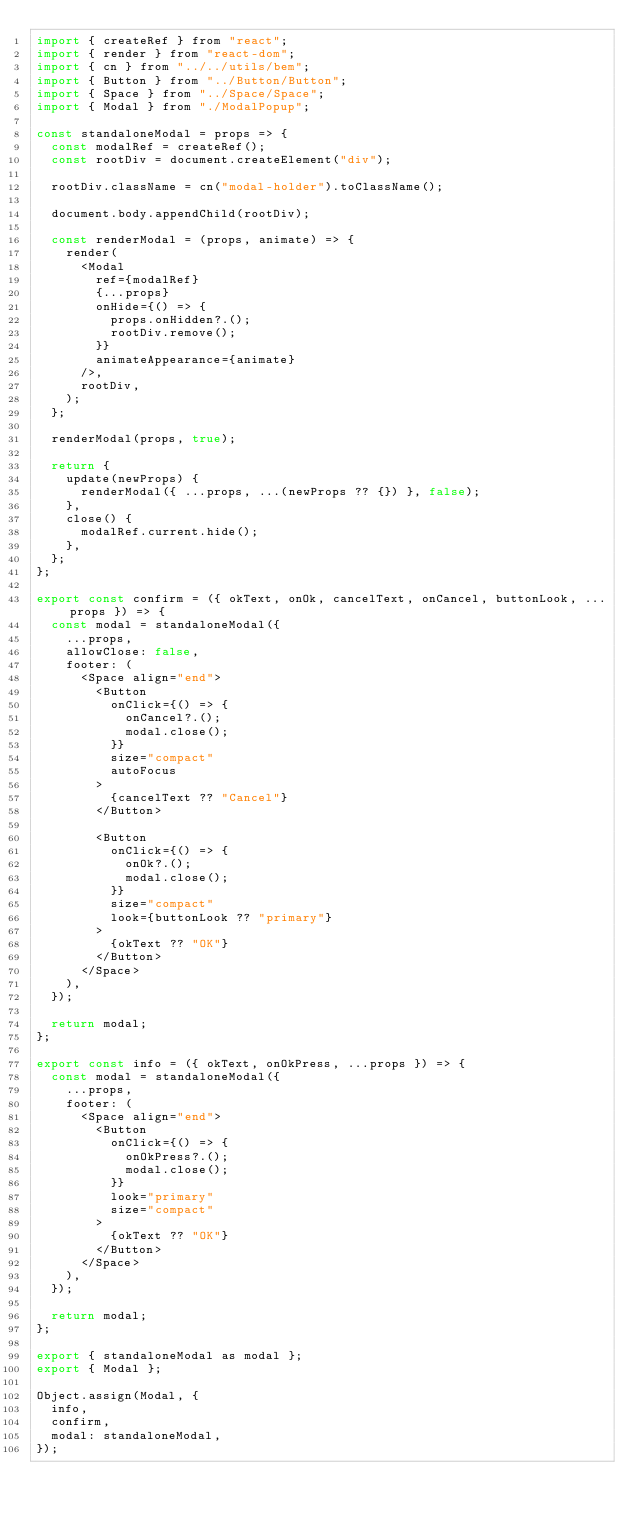<code> <loc_0><loc_0><loc_500><loc_500><_JavaScript_>import { createRef } from "react";
import { render } from "react-dom";
import { cn } from "../../utils/bem";
import { Button } from "../Button/Button";
import { Space } from "../Space/Space";
import { Modal } from "./ModalPopup";

const standaloneModal = props => {
  const modalRef = createRef();
  const rootDiv = document.createElement("div");

  rootDiv.className = cn("modal-holder").toClassName();

  document.body.appendChild(rootDiv);

  const renderModal = (props, animate) => {
    render(
      <Modal
        ref={modalRef}
        {...props}
        onHide={() => {
          props.onHidden?.();
          rootDiv.remove();
        }}
        animateAppearance={animate}
      />,
      rootDiv,
    );
  };

  renderModal(props, true);

  return {
    update(newProps) {
      renderModal({ ...props, ...(newProps ?? {}) }, false);
    },
    close() {
      modalRef.current.hide();
    },
  };
};

export const confirm = ({ okText, onOk, cancelText, onCancel, buttonLook, ...props }) => {
  const modal = standaloneModal({
    ...props,
    allowClose: false,
    footer: (
      <Space align="end">
        <Button
          onClick={() => {
            onCancel?.();
            modal.close();
          }}
          size="compact"
          autoFocus
        >
          {cancelText ?? "Cancel"}
        </Button>

        <Button
          onClick={() => {
            onOk?.();
            modal.close();
          }}
          size="compact"
          look={buttonLook ?? "primary"}
        >
          {okText ?? "OK"}
        </Button>
      </Space>
    ),
  });

  return modal;
};

export const info = ({ okText, onOkPress, ...props }) => {
  const modal = standaloneModal({
    ...props,
    footer: (
      <Space align="end">
        <Button
          onClick={() => {
            onOkPress?.();
            modal.close();
          }}
          look="primary"
          size="compact"
        >
          {okText ?? "OK"}
        </Button>
      </Space>
    ),
  });

  return modal;
};

export { standaloneModal as modal };
export { Modal };

Object.assign(Modal, {
  info,
  confirm,
  modal: standaloneModal,
});
</code> 